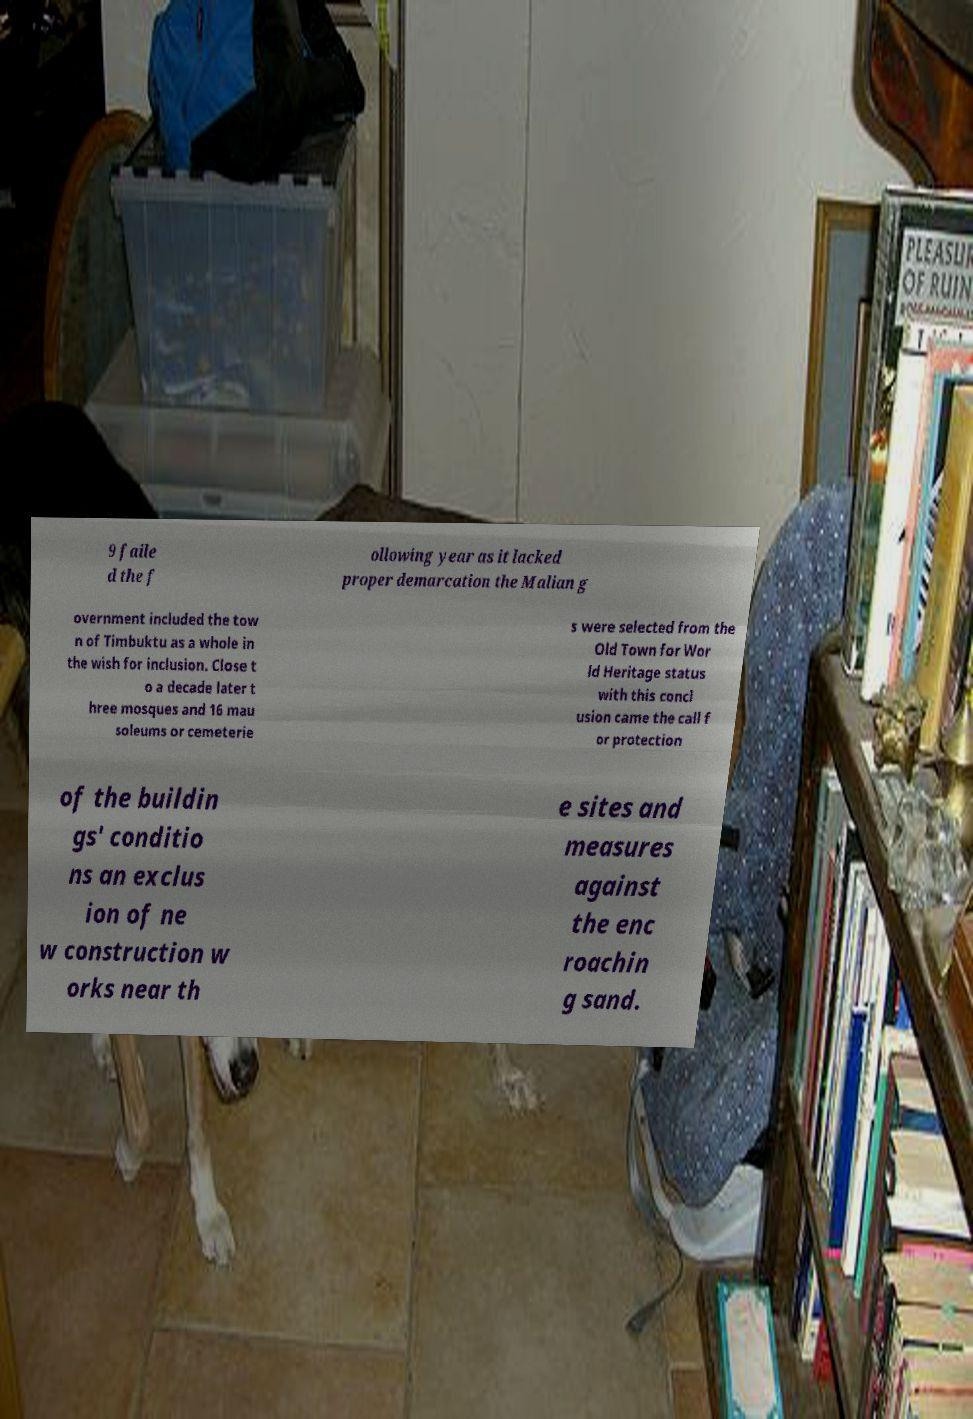For documentation purposes, I need the text within this image transcribed. Could you provide that? 9 faile d the f ollowing year as it lacked proper demarcation the Malian g overnment included the tow n of Timbuktu as a whole in the wish for inclusion. Close t o a decade later t hree mosques and 16 mau soleums or cemeterie s were selected from the Old Town for Wor ld Heritage status with this concl usion came the call f or protection of the buildin gs' conditio ns an exclus ion of ne w construction w orks near th e sites and measures against the enc roachin g sand. 